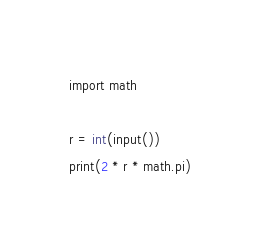<code> <loc_0><loc_0><loc_500><loc_500><_C_>import math

r = int(input())
print(2 * r * math.pi)</code> 